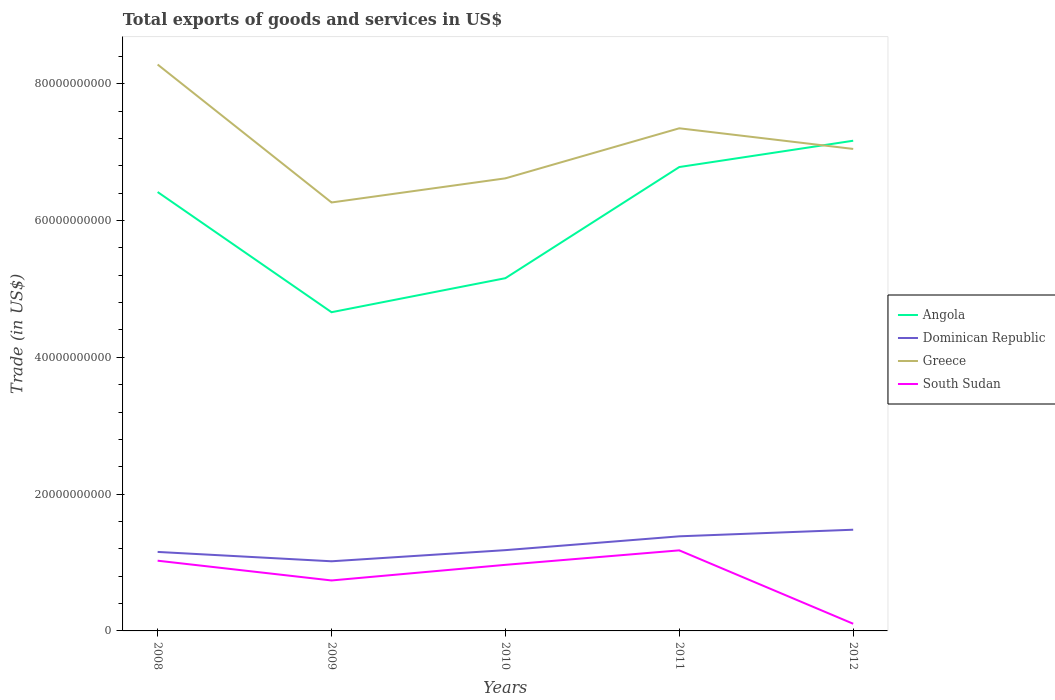Across all years, what is the maximum total exports of goods and services in South Sudan?
Your response must be concise. 1.05e+09. What is the total total exports of goods and services in Dominican Republic in the graph?
Keep it short and to the point. -9.64e+08. What is the difference between the highest and the second highest total exports of goods and services in South Sudan?
Provide a succinct answer. 1.07e+1. How many lines are there?
Ensure brevity in your answer.  4. What is the difference between two consecutive major ticks on the Y-axis?
Give a very brief answer. 2.00e+1. Where does the legend appear in the graph?
Ensure brevity in your answer.  Center right. How many legend labels are there?
Your answer should be very brief. 4. How are the legend labels stacked?
Provide a succinct answer. Vertical. What is the title of the graph?
Give a very brief answer. Total exports of goods and services in US$. What is the label or title of the X-axis?
Offer a very short reply. Years. What is the label or title of the Y-axis?
Offer a terse response. Trade (in US$). What is the Trade (in US$) of Angola in 2008?
Make the answer very short. 6.42e+1. What is the Trade (in US$) of Dominican Republic in 2008?
Ensure brevity in your answer.  1.16e+1. What is the Trade (in US$) in Greece in 2008?
Make the answer very short. 8.28e+1. What is the Trade (in US$) in South Sudan in 2008?
Keep it short and to the point. 1.03e+1. What is the Trade (in US$) of Angola in 2009?
Ensure brevity in your answer.  4.66e+1. What is the Trade (in US$) in Dominican Republic in 2009?
Ensure brevity in your answer.  1.02e+1. What is the Trade (in US$) in Greece in 2009?
Keep it short and to the point. 6.26e+1. What is the Trade (in US$) of South Sudan in 2009?
Ensure brevity in your answer.  7.38e+09. What is the Trade (in US$) of Angola in 2010?
Make the answer very short. 5.16e+1. What is the Trade (in US$) in Dominican Republic in 2010?
Ensure brevity in your answer.  1.18e+1. What is the Trade (in US$) in Greece in 2010?
Offer a terse response. 6.62e+1. What is the Trade (in US$) in South Sudan in 2010?
Make the answer very short. 9.66e+09. What is the Trade (in US$) of Angola in 2011?
Offer a terse response. 6.78e+1. What is the Trade (in US$) of Dominican Republic in 2011?
Make the answer very short. 1.38e+1. What is the Trade (in US$) in Greece in 2011?
Your answer should be very brief. 7.35e+1. What is the Trade (in US$) of South Sudan in 2011?
Provide a succinct answer. 1.18e+1. What is the Trade (in US$) in Angola in 2012?
Give a very brief answer. 7.17e+1. What is the Trade (in US$) in Dominican Republic in 2012?
Offer a very short reply. 1.48e+1. What is the Trade (in US$) in Greece in 2012?
Your answer should be compact. 7.05e+1. What is the Trade (in US$) of South Sudan in 2012?
Keep it short and to the point. 1.05e+09. Across all years, what is the maximum Trade (in US$) in Angola?
Your response must be concise. 7.17e+1. Across all years, what is the maximum Trade (in US$) of Dominican Republic?
Offer a terse response. 1.48e+1. Across all years, what is the maximum Trade (in US$) in Greece?
Ensure brevity in your answer.  8.28e+1. Across all years, what is the maximum Trade (in US$) of South Sudan?
Make the answer very short. 1.18e+1. Across all years, what is the minimum Trade (in US$) in Angola?
Offer a very short reply. 4.66e+1. Across all years, what is the minimum Trade (in US$) in Dominican Republic?
Offer a very short reply. 1.02e+1. Across all years, what is the minimum Trade (in US$) in Greece?
Give a very brief answer. 6.26e+1. Across all years, what is the minimum Trade (in US$) of South Sudan?
Your response must be concise. 1.05e+09. What is the total Trade (in US$) of Angola in the graph?
Your answer should be compact. 3.02e+11. What is the total Trade (in US$) in Dominican Republic in the graph?
Ensure brevity in your answer.  6.22e+1. What is the total Trade (in US$) of Greece in the graph?
Make the answer very short. 3.56e+11. What is the total Trade (in US$) of South Sudan in the graph?
Your response must be concise. 4.01e+1. What is the difference between the Trade (in US$) of Angola in 2008 and that in 2009?
Your response must be concise. 1.76e+1. What is the difference between the Trade (in US$) of Dominican Republic in 2008 and that in 2009?
Your answer should be compact. 1.37e+09. What is the difference between the Trade (in US$) of Greece in 2008 and that in 2009?
Give a very brief answer. 2.02e+1. What is the difference between the Trade (in US$) in South Sudan in 2008 and that in 2009?
Offer a very short reply. 2.89e+09. What is the difference between the Trade (in US$) of Angola in 2008 and that in 2010?
Your answer should be very brief. 1.26e+1. What is the difference between the Trade (in US$) of Dominican Republic in 2008 and that in 2010?
Offer a terse response. -2.59e+08. What is the difference between the Trade (in US$) in Greece in 2008 and that in 2010?
Offer a terse response. 1.66e+1. What is the difference between the Trade (in US$) of South Sudan in 2008 and that in 2010?
Your answer should be compact. 6.05e+08. What is the difference between the Trade (in US$) of Angola in 2008 and that in 2011?
Keep it short and to the point. -3.65e+09. What is the difference between the Trade (in US$) in Dominican Republic in 2008 and that in 2011?
Provide a short and direct response. -2.28e+09. What is the difference between the Trade (in US$) in Greece in 2008 and that in 2011?
Keep it short and to the point. 9.32e+09. What is the difference between the Trade (in US$) in South Sudan in 2008 and that in 2011?
Your answer should be compact. -1.51e+09. What is the difference between the Trade (in US$) in Angola in 2008 and that in 2012?
Give a very brief answer. -7.50e+09. What is the difference between the Trade (in US$) in Dominican Republic in 2008 and that in 2012?
Provide a short and direct response. -3.24e+09. What is the difference between the Trade (in US$) in Greece in 2008 and that in 2012?
Your answer should be compact. 1.23e+1. What is the difference between the Trade (in US$) of South Sudan in 2008 and that in 2012?
Ensure brevity in your answer.  9.22e+09. What is the difference between the Trade (in US$) in Angola in 2009 and that in 2010?
Your answer should be very brief. -4.98e+09. What is the difference between the Trade (in US$) of Dominican Republic in 2009 and that in 2010?
Make the answer very short. -1.63e+09. What is the difference between the Trade (in US$) of Greece in 2009 and that in 2010?
Make the answer very short. -3.53e+09. What is the difference between the Trade (in US$) in South Sudan in 2009 and that in 2010?
Your response must be concise. -2.28e+09. What is the difference between the Trade (in US$) in Angola in 2009 and that in 2011?
Keep it short and to the point. -2.12e+1. What is the difference between the Trade (in US$) of Dominican Republic in 2009 and that in 2011?
Your answer should be very brief. -3.65e+09. What is the difference between the Trade (in US$) of Greece in 2009 and that in 2011?
Ensure brevity in your answer.  -1.08e+1. What is the difference between the Trade (in US$) in South Sudan in 2009 and that in 2011?
Give a very brief answer. -4.40e+09. What is the difference between the Trade (in US$) of Angola in 2009 and that in 2012?
Provide a succinct answer. -2.51e+1. What is the difference between the Trade (in US$) of Dominican Republic in 2009 and that in 2012?
Give a very brief answer. -4.61e+09. What is the difference between the Trade (in US$) in Greece in 2009 and that in 2012?
Your answer should be very brief. -7.83e+09. What is the difference between the Trade (in US$) in South Sudan in 2009 and that in 2012?
Your answer should be compact. 6.33e+09. What is the difference between the Trade (in US$) of Angola in 2010 and that in 2011?
Your answer should be very brief. -1.62e+1. What is the difference between the Trade (in US$) of Dominican Republic in 2010 and that in 2011?
Your response must be concise. -2.02e+09. What is the difference between the Trade (in US$) of Greece in 2010 and that in 2011?
Your response must be concise. -7.32e+09. What is the difference between the Trade (in US$) of South Sudan in 2010 and that in 2011?
Make the answer very short. -2.12e+09. What is the difference between the Trade (in US$) of Angola in 2010 and that in 2012?
Provide a succinct answer. -2.01e+1. What is the difference between the Trade (in US$) of Dominican Republic in 2010 and that in 2012?
Ensure brevity in your answer.  -2.99e+09. What is the difference between the Trade (in US$) in Greece in 2010 and that in 2012?
Keep it short and to the point. -4.30e+09. What is the difference between the Trade (in US$) in South Sudan in 2010 and that in 2012?
Provide a short and direct response. 8.61e+09. What is the difference between the Trade (in US$) of Angola in 2011 and that in 2012?
Offer a terse response. -3.85e+09. What is the difference between the Trade (in US$) of Dominican Republic in 2011 and that in 2012?
Offer a terse response. -9.64e+08. What is the difference between the Trade (in US$) of Greece in 2011 and that in 2012?
Provide a short and direct response. 3.02e+09. What is the difference between the Trade (in US$) in South Sudan in 2011 and that in 2012?
Ensure brevity in your answer.  1.07e+1. What is the difference between the Trade (in US$) of Angola in 2008 and the Trade (in US$) of Dominican Republic in 2009?
Your answer should be compact. 5.40e+1. What is the difference between the Trade (in US$) of Angola in 2008 and the Trade (in US$) of Greece in 2009?
Give a very brief answer. 1.53e+09. What is the difference between the Trade (in US$) in Angola in 2008 and the Trade (in US$) in South Sudan in 2009?
Keep it short and to the point. 5.68e+1. What is the difference between the Trade (in US$) in Dominican Republic in 2008 and the Trade (in US$) in Greece in 2009?
Give a very brief answer. -5.11e+1. What is the difference between the Trade (in US$) in Dominican Republic in 2008 and the Trade (in US$) in South Sudan in 2009?
Offer a terse response. 4.17e+09. What is the difference between the Trade (in US$) in Greece in 2008 and the Trade (in US$) in South Sudan in 2009?
Provide a succinct answer. 7.54e+1. What is the difference between the Trade (in US$) in Angola in 2008 and the Trade (in US$) in Dominican Republic in 2010?
Provide a short and direct response. 5.24e+1. What is the difference between the Trade (in US$) of Angola in 2008 and the Trade (in US$) of Greece in 2010?
Offer a very short reply. -2.00e+09. What is the difference between the Trade (in US$) in Angola in 2008 and the Trade (in US$) in South Sudan in 2010?
Keep it short and to the point. 5.45e+1. What is the difference between the Trade (in US$) of Dominican Republic in 2008 and the Trade (in US$) of Greece in 2010?
Give a very brief answer. -5.46e+1. What is the difference between the Trade (in US$) of Dominican Republic in 2008 and the Trade (in US$) of South Sudan in 2010?
Your answer should be very brief. 1.89e+09. What is the difference between the Trade (in US$) of Greece in 2008 and the Trade (in US$) of South Sudan in 2010?
Your response must be concise. 7.31e+1. What is the difference between the Trade (in US$) in Angola in 2008 and the Trade (in US$) in Dominican Republic in 2011?
Make the answer very short. 5.03e+1. What is the difference between the Trade (in US$) of Angola in 2008 and the Trade (in US$) of Greece in 2011?
Ensure brevity in your answer.  -9.32e+09. What is the difference between the Trade (in US$) of Angola in 2008 and the Trade (in US$) of South Sudan in 2011?
Ensure brevity in your answer.  5.24e+1. What is the difference between the Trade (in US$) of Dominican Republic in 2008 and the Trade (in US$) of Greece in 2011?
Your answer should be very brief. -6.19e+1. What is the difference between the Trade (in US$) in Dominican Republic in 2008 and the Trade (in US$) in South Sudan in 2011?
Provide a succinct answer. -2.28e+08. What is the difference between the Trade (in US$) of Greece in 2008 and the Trade (in US$) of South Sudan in 2011?
Offer a terse response. 7.10e+1. What is the difference between the Trade (in US$) in Angola in 2008 and the Trade (in US$) in Dominican Republic in 2012?
Offer a terse response. 4.94e+1. What is the difference between the Trade (in US$) of Angola in 2008 and the Trade (in US$) of Greece in 2012?
Keep it short and to the point. -6.30e+09. What is the difference between the Trade (in US$) in Angola in 2008 and the Trade (in US$) in South Sudan in 2012?
Offer a very short reply. 6.31e+1. What is the difference between the Trade (in US$) of Dominican Republic in 2008 and the Trade (in US$) of Greece in 2012?
Offer a terse response. -5.89e+1. What is the difference between the Trade (in US$) in Dominican Republic in 2008 and the Trade (in US$) in South Sudan in 2012?
Your answer should be very brief. 1.05e+1. What is the difference between the Trade (in US$) in Greece in 2008 and the Trade (in US$) in South Sudan in 2012?
Provide a succinct answer. 8.18e+1. What is the difference between the Trade (in US$) of Angola in 2009 and the Trade (in US$) of Dominican Republic in 2010?
Make the answer very short. 3.48e+1. What is the difference between the Trade (in US$) in Angola in 2009 and the Trade (in US$) in Greece in 2010?
Ensure brevity in your answer.  -1.96e+1. What is the difference between the Trade (in US$) in Angola in 2009 and the Trade (in US$) in South Sudan in 2010?
Make the answer very short. 3.69e+1. What is the difference between the Trade (in US$) in Dominican Republic in 2009 and the Trade (in US$) in Greece in 2010?
Give a very brief answer. -5.60e+1. What is the difference between the Trade (in US$) of Dominican Republic in 2009 and the Trade (in US$) of South Sudan in 2010?
Your answer should be very brief. 5.20e+08. What is the difference between the Trade (in US$) of Greece in 2009 and the Trade (in US$) of South Sudan in 2010?
Make the answer very short. 5.30e+1. What is the difference between the Trade (in US$) in Angola in 2009 and the Trade (in US$) in Dominican Republic in 2011?
Give a very brief answer. 3.28e+1. What is the difference between the Trade (in US$) in Angola in 2009 and the Trade (in US$) in Greece in 2011?
Keep it short and to the point. -2.69e+1. What is the difference between the Trade (in US$) in Angola in 2009 and the Trade (in US$) in South Sudan in 2011?
Offer a terse response. 3.48e+1. What is the difference between the Trade (in US$) of Dominican Republic in 2009 and the Trade (in US$) of Greece in 2011?
Keep it short and to the point. -6.33e+1. What is the difference between the Trade (in US$) in Dominican Republic in 2009 and the Trade (in US$) in South Sudan in 2011?
Your response must be concise. -1.60e+09. What is the difference between the Trade (in US$) in Greece in 2009 and the Trade (in US$) in South Sudan in 2011?
Your response must be concise. 5.09e+1. What is the difference between the Trade (in US$) of Angola in 2009 and the Trade (in US$) of Dominican Republic in 2012?
Provide a succinct answer. 3.18e+1. What is the difference between the Trade (in US$) in Angola in 2009 and the Trade (in US$) in Greece in 2012?
Make the answer very short. -2.39e+1. What is the difference between the Trade (in US$) in Angola in 2009 and the Trade (in US$) in South Sudan in 2012?
Your answer should be very brief. 4.55e+1. What is the difference between the Trade (in US$) in Dominican Republic in 2009 and the Trade (in US$) in Greece in 2012?
Provide a short and direct response. -6.03e+1. What is the difference between the Trade (in US$) in Dominican Republic in 2009 and the Trade (in US$) in South Sudan in 2012?
Your response must be concise. 9.13e+09. What is the difference between the Trade (in US$) in Greece in 2009 and the Trade (in US$) in South Sudan in 2012?
Ensure brevity in your answer.  6.16e+1. What is the difference between the Trade (in US$) of Angola in 2010 and the Trade (in US$) of Dominican Republic in 2011?
Your response must be concise. 3.77e+1. What is the difference between the Trade (in US$) in Angola in 2010 and the Trade (in US$) in Greece in 2011?
Make the answer very short. -2.19e+1. What is the difference between the Trade (in US$) of Angola in 2010 and the Trade (in US$) of South Sudan in 2011?
Give a very brief answer. 3.98e+1. What is the difference between the Trade (in US$) in Dominican Republic in 2010 and the Trade (in US$) in Greece in 2011?
Make the answer very short. -6.17e+1. What is the difference between the Trade (in US$) of Dominican Republic in 2010 and the Trade (in US$) of South Sudan in 2011?
Your answer should be very brief. 3.08e+07. What is the difference between the Trade (in US$) in Greece in 2010 and the Trade (in US$) in South Sudan in 2011?
Make the answer very short. 5.44e+1. What is the difference between the Trade (in US$) of Angola in 2010 and the Trade (in US$) of Dominican Republic in 2012?
Your answer should be compact. 3.68e+1. What is the difference between the Trade (in US$) of Angola in 2010 and the Trade (in US$) of Greece in 2012?
Ensure brevity in your answer.  -1.89e+1. What is the difference between the Trade (in US$) of Angola in 2010 and the Trade (in US$) of South Sudan in 2012?
Provide a short and direct response. 5.05e+1. What is the difference between the Trade (in US$) in Dominican Republic in 2010 and the Trade (in US$) in Greece in 2012?
Offer a very short reply. -5.87e+1. What is the difference between the Trade (in US$) in Dominican Republic in 2010 and the Trade (in US$) in South Sudan in 2012?
Provide a short and direct response. 1.08e+1. What is the difference between the Trade (in US$) of Greece in 2010 and the Trade (in US$) of South Sudan in 2012?
Offer a very short reply. 6.51e+1. What is the difference between the Trade (in US$) in Angola in 2011 and the Trade (in US$) in Dominican Republic in 2012?
Give a very brief answer. 5.30e+1. What is the difference between the Trade (in US$) of Angola in 2011 and the Trade (in US$) of Greece in 2012?
Offer a terse response. -2.65e+09. What is the difference between the Trade (in US$) of Angola in 2011 and the Trade (in US$) of South Sudan in 2012?
Give a very brief answer. 6.68e+1. What is the difference between the Trade (in US$) in Dominican Republic in 2011 and the Trade (in US$) in Greece in 2012?
Offer a terse response. -5.66e+1. What is the difference between the Trade (in US$) of Dominican Republic in 2011 and the Trade (in US$) of South Sudan in 2012?
Make the answer very short. 1.28e+1. What is the difference between the Trade (in US$) in Greece in 2011 and the Trade (in US$) in South Sudan in 2012?
Offer a very short reply. 7.24e+1. What is the average Trade (in US$) in Angola per year?
Keep it short and to the point. 6.04e+1. What is the average Trade (in US$) of Dominican Republic per year?
Offer a very short reply. 1.24e+1. What is the average Trade (in US$) of Greece per year?
Provide a short and direct response. 7.11e+1. What is the average Trade (in US$) in South Sudan per year?
Your answer should be very brief. 8.03e+09. In the year 2008, what is the difference between the Trade (in US$) of Angola and Trade (in US$) of Dominican Republic?
Provide a short and direct response. 5.26e+1. In the year 2008, what is the difference between the Trade (in US$) of Angola and Trade (in US$) of Greece?
Provide a short and direct response. -1.86e+1. In the year 2008, what is the difference between the Trade (in US$) in Angola and Trade (in US$) in South Sudan?
Keep it short and to the point. 5.39e+1. In the year 2008, what is the difference between the Trade (in US$) in Dominican Republic and Trade (in US$) in Greece?
Give a very brief answer. -7.13e+1. In the year 2008, what is the difference between the Trade (in US$) in Dominican Republic and Trade (in US$) in South Sudan?
Make the answer very short. 1.28e+09. In the year 2008, what is the difference between the Trade (in US$) of Greece and Trade (in US$) of South Sudan?
Keep it short and to the point. 7.25e+1. In the year 2009, what is the difference between the Trade (in US$) of Angola and Trade (in US$) of Dominican Republic?
Provide a succinct answer. 3.64e+1. In the year 2009, what is the difference between the Trade (in US$) of Angola and Trade (in US$) of Greece?
Your answer should be very brief. -1.60e+1. In the year 2009, what is the difference between the Trade (in US$) in Angola and Trade (in US$) in South Sudan?
Provide a short and direct response. 3.92e+1. In the year 2009, what is the difference between the Trade (in US$) of Dominican Republic and Trade (in US$) of Greece?
Your answer should be compact. -5.25e+1. In the year 2009, what is the difference between the Trade (in US$) in Dominican Republic and Trade (in US$) in South Sudan?
Your answer should be very brief. 2.80e+09. In the year 2009, what is the difference between the Trade (in US$) in Greece and Trade (in US$) in South Sudan?
Provide a short and direct response. 5.53e+1. In the year 2010, what is the difference between the Trade (in US$) of Angola and Trade (in US$) of Dominican Republic?
Your answer should be very brief. 3.98e+1. In the year 2010, what is the difference between the Trade (in US$) in Angola and Trade (in US$) in Greece?
Ensure brevity in your answer.  -1.46e+1. In the year 2010, what is the difference between the Trade (in US$) of Angola and Trade (in US$) of South Sudan?
Provide a short and direct response. 4.19e+1. In the year 2010, what is the difference between the Trade (in US$) in Dominican Republic and Trade (in US$) in Greece?
Provide a succinct answer. -5.44e+1. In the year 2010, what is the difference between the Trade (in US$) of Dominican Republic and Trade (in US$) of South Sudan?
Ensure brevity in your answer.  2.15e+09. In the year 2010, what is the difference between the Trade (in US$) in Greece and Trade (in US$) in South Sudan?
Ensure brevity in your answer.  5.65e+1. In the year 2011, what is the difference between the Trade (in US$) of Angola and Trade (in US$) of Dominican Republic?
Make the answer very short. 5.40e+1. In the year 2011, what is the difference between the Trade (in US$) of Angola and Trade (in US$) of Greece?
Ensure brevity in your answer.  -5.66e+09. In the year 2011, what is the difference between the Trade (in US$) of Angola and Trade (in US$) of South Sudan?
Your response must be concise. 5.60e+1. In the year 2011, what is the difference between the Trade (in US$) in Dominican Republic and Trade (in US$) in Greece?
Keep it short and to the point. -5.97e+1. In the year 2011, what is the difference between the Trade (in US$) in Dominican Republic and Trade (in US$) in South Sudan?
Your answer should be very brief. 2.05e+09. In the year 2011, what is the difference between the Trade (in US$) in Greece and Trade (in US$) in South Sudan?
Keep it short and to the point. 6.17e+1. In the year 2012, what is the difference between the Trade (in US$) in Angola and Trade (in US$) in Dominican Republic?
Your answer should be very brief. 5.69e+1. In the year 2012, what is the difference between the Trade (in US$) in Angola and Trade (in US$) in Greece?
Your answer should be very brief. 1.20e+09. In the year 2012, what is the difference between the Trade (in US$) of Angola and Trade (in US$) of South Sudan?
Ensure brevity in your answer.  7.06e+1. In the year 2012, what is the difference between the Trade (in US$) of Dominican Republic and Trade (in US$) of Greece?
Make the answer very short. -5.57e+1. In the year 2012, what is the difference between the Trade (in US$) in Dominican Republic and Trade (in US$) in South Sudan?
Keep it short and to the point. 1.37e+1. In the year 2012, what is the difference between the Trade (in US$) of Greece and Trade (in US$) of South Sudan?
Your answer should be very brief. 6.94e+1. What is the ratio of the Trade (in US$) of Angola in 2008 to that in 2009?
Offer a very short reply. 1.38. What is the ratio of the Trade (in US$) in Dominican Republic in 2008 to that in 2009?
Your response must be concise. 1.13. What is the ratio of the Trade (in US$) in Greece in 2008 to that in 2009?
Offer a very short reply. 1.32. What is the ratio of the Trade (in US$) in South Sudan in 2008 to that in 2009?
Your answer should be very brief. 1.39. What is the ratio of the Trade (in US$) of Angola in 2008 to that in 2010?
Offer a terse response. 1.24. What is the ratio of the Trade (in US$) in Dominican Republic in 2008 to that in 2010?
Your answer should be compact. 0.98. What is the ratio of the Trade (in US$) in Greece in 2008 to that in 2010?
Offer a terse response. 1.25. What is the ratio of the Trade (in US$) in South Sudan in 2008 to that in 2010?
Ensure brevity in your answer.  1.06. What is the ratio of the Trade (in US$) of Angola in 2008 to that in 2011?
Provide a short and direct response. 0.95. What is the ratio of the Trade (in US$) in Dominican Republic in 2008 to that in 2011?
Offer a very short reply. 0.84. What is the ratio of the Trade (in US$) in Greece in 2008 to that in 2011?
Ensure brevity in your answer.  1.13. What is the ratio of the Trade (in US$) of South Sudan in 2008 to that in 2011?
Offer a terse response. 0.87. What is the ratio of the Trade (in US$) in Angola in 2008 to that in 2012?
Your answer should be compact. 0.9. What is the ratio of the Trade (in US$) in Dominican Republic in 2008 to that in 2012?
Your answer should be compact. 0.78. What is the ratio of the Trade (in US$) of Greece in 2008 to that in 2012?
Provide a succinct answer. 1.18. What is the ratio of the Trade (in US$) of South Sudan in 2008 to that in 2012?
Your answer should be very brief. 9.78. What is the ratio of the Trade (in US$) of Angola in 2009 to that in 2010?
Your response must be concise. 0.9. What is the ratio of the Trade (in US$) of Dominican Republic in 2009 to that in 2010?
Your answer should be very brief. 0.86. What is the ratio of the Trade (in US$) in Greece in 2009 to that in 2010?
Your response must be concise. 0.95. What is the ratio of the Trade (in US$) of South Sudan in 2009 to that in 2010?
Provide a short and direct response. 0.76. What is the ratio of the Trade (in US$) of Angola in 2009 to that in 2011?
Provide a succinct answer. 0.69. What is the ratio of the Trade (in US$) of Dominican Republic in 2009 to that in 2011?
Your response must be concise. 0.74. What is the ratio of the Trade (in US$) of Greece in 2009 to that in 2011?
Your answer should be compact. 0.85. What is the ratio of the Trade (in US$) in South Sudan in 2009 to that in 2011?
Offer a terse response. 0.63. What is the ratio of the Trade (in US$) in Angola in 2009 to that in 2012?
Ensure brevity in your answer.  0.65. What is the ratio of the Trade (in US$) of Dominican Republic in 2009 to that in 2012?
Give a very brief answer. 0.69. What is the ratio of the Trade (in US$) of South Sudan in 2009 to that in 2012?
Keep it short and to the point. 7.03. What is the ratio of the Trade (in US$) of Angola in 2010 to that in 2011?
Keep it short and to the point. 0.76. What is the ratio of the Trade (in US$) in Dominican Republic in 2010 to that in 2011?
Your answer should be very brief. 0.85. What is the ratio of the Trade (in US$) in Greece in 2010 to that in 2011?
Keep it short and to the point. 0.9. What is the ratio of the Trade (in US$) of South Sudan in 2010 to that in 2011?
Keep it short and to the point. 0.82. What is the ratio of the Trade (in US$) in Angola in 2010 to that in 2012?
Your response must be concise. 0.72. What is the ratio of the Trade (in US$) of Dominican Republic in 2010 to that in 2012?
Ensure brevity in your answer.  0.8. What is the ratio of the Trade (in US$) of Greece in 2010 to that in 2012?
Give a very brief answer. 0.94. What is the ratio of the Trade (in US$) in South Sudan in 2010 to that in 2012?
Make the answer very short. 9.21. What is the ratio of the Trade (in US$) of Angola in 2011 to that in 2012?
Offer a very short reply. 0.95. What is the ratio of the Trade (in US$) of Dominican Republic in 2011 to that in 2012?
Offer a terse response. 0.93. What is the ratio of the Trade (in US$) of Greece in 2011 to that in 2012?
Make the answer very short. 1.04. What is the ratio of the Trade (in US$) in South Sudan in 2011 to that in 2012?
Offer a very short reply. 11.22. What is the difference between the highest and the second highest Trade (in US$) in Angola?
Ensure brevity in your answer.  3.85e+09. What is the difference between the highest and the second highest Trade (in US$) of Dominican Republic?
Your response must be concise. 9.64e+08. What is the difference between the highest and the second highest Trade (in US$) in Greece?
Give a very brief answer. 9.32e+09. What is the difference between the highest and the second highest Trade (in US$) of South Sudan?
Provide a succinct answer. 1.51e+09. What is the difference between the highest and the lowest Trade (in US$) in Angola?
Your answer should be very brief. 2.51e+1. What is the difference between the highest and the lowest Trade (in US$) of Dominican Republic?
Keep it short and to the point. 4.61e+09. What is the difference between the highest and the lowest Trade (in US$) in Greece?
Offer a very short reply. 2.02e+1. What is the difference between the highest and the lowest Trade (in US$) of South Sudan?
Offer a very short reply. 1.07e+1. 